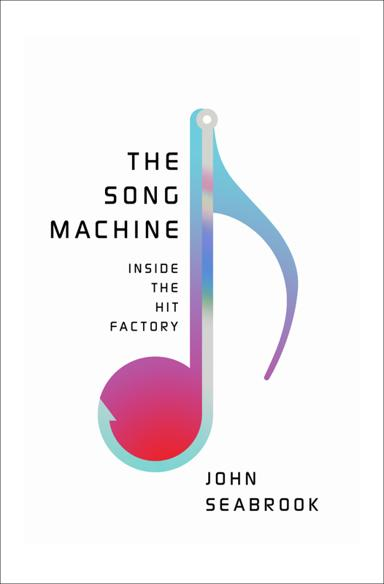Can you provide a brief overview of what "The Song Machine" book is about? 'The Song Machine: Inside the Hit Factory' explores the intricate world of pop music production. Author John Seabrook provides a behind-the-scenes look at how technological advancements and creative processes combine to produce hit songs that dominate charts worldwide. He examines the collaborations between songwriters, producers, and artists, and details how these hits influence global culture. It's an insightful read for anyone interested in the dynamics that drive modern popular music and the evolving landscape of the music industry. 